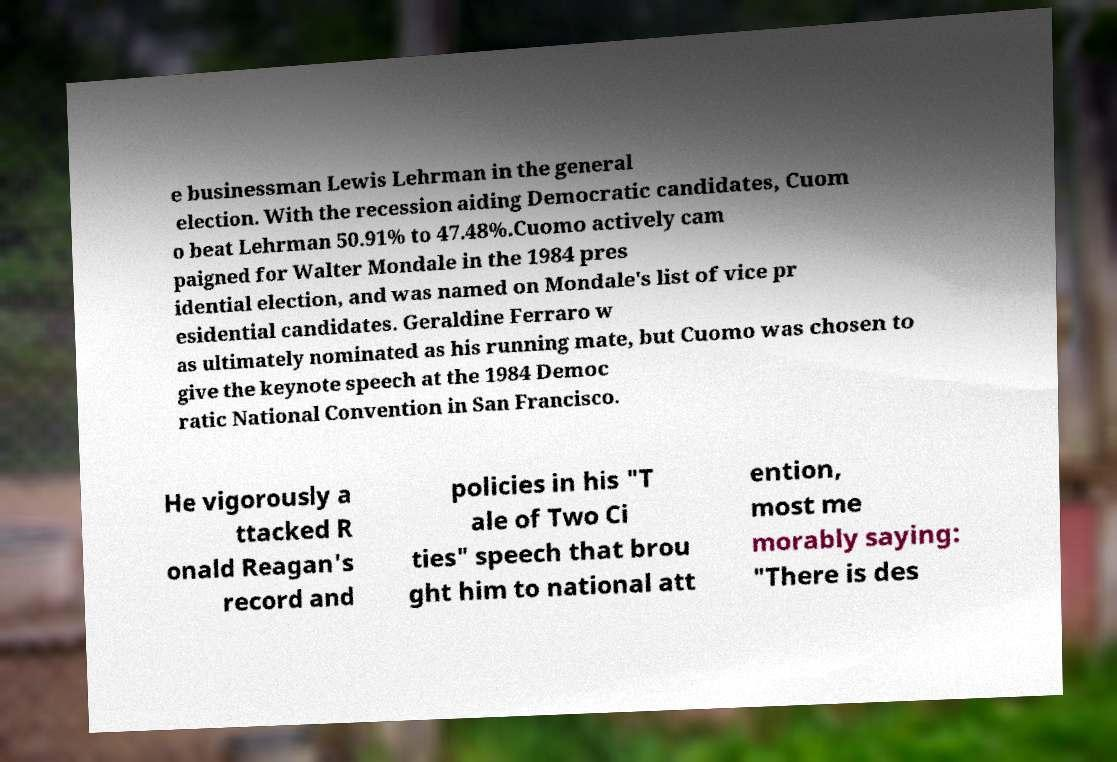Please read and relay the text visible in this image. What does it say? e businessman Lewis Lehrman in the general election. With the recession aiding Democratic candidates, Cuom o beat Lehrman 50.91% to 47.48%.Cuomo actively cam paigned for Walter Mondale in the 1984 pres idential election, and was named on Mondale's list of vice pr esidential candidates. Geraldine Ferraro w as ultimately nominated as his running mate, but Cuomo was chosen to give the keynote speech at the 1984 Democ ratic National Convention in San Francisco. He vigorously a ttacked R onald Reagan's record and policies in his "T ale of Two Ci ties" speech that brou ght him to national att ention, most me morably saying: "There is des 